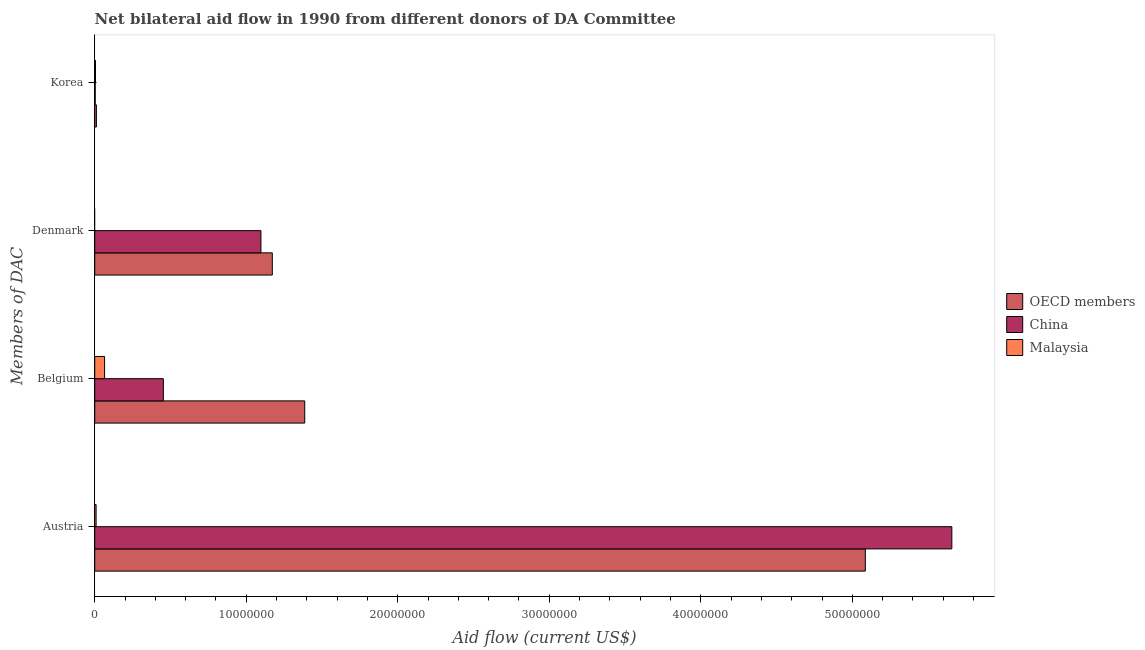How many different coloured bars are there?
Ensure brevity in your answer.  3. How many groups of bars are there?
Your answer should be very brief. 4. Are the number of bars per tick equal to the number of legend labels?
Make the answer very short. No. What is the label of the 1st group of bars from the top?
Ensure brevity in your answer.  Korea. What is the amount of aid given by austria in OECD members?
Provide a succinct answer. 5.09e+07. Across all countries, what is the maximum amount of aid given by korea?
Your response must be concise. 1.10e+05. Across all countries, what is the minimum amount of aid given by denmark?
Your response must be concise. 0. What is the total amount of aid given by denmark in the graph?
Keep it short and to the point. 2.27e+07. What is the difference between the amount of aid given by korea in OECD members and that in Malaysia?
Your answer should be very brief. 6.00e+04. What is the difference between the amount of aid given by denmark in OECD members and the amount of aid given by korea in China?
Offer a very short reply. 1.17e+07. What is the average amount of aid given by belgium per country?
Give a very brief answer. 6.35e+06. What is the difference between the amount of aid given by korea and amount of aid given by denmark in OECD members?
Your answer should be compact. -1.16e+07. In how many countries, is the amount of aid given by korea greater than 4000000 US$?
Your answer should be very brief. 0. What is the ratio of the amount of aid given by belgium in China to that in Malaysia?
Keep it short and to the point. 6.97. Is the difference between the amount of aid given by korea in OECD members and China greater than the difference between the amount of aid given by denmark in OECD members and China?
Offer a very short reply. No. What is the difference between the highest and the second highest amount of aid given by belgium?
Give a very brief answer. 9.33e+06. What is the difference between the highest and the lowest amount of aid given by belgium?
Provide a short and direct response. 1.32e+07. In how many countries, is the amount of aid given by korea greater than the average amount of aid given by korea taken over all countries?
Ensure brevity in your answer.  1. Is the sum of the amount of aid given by korea in China and Malaysia greater than the maximum amount of aid given by belgium across all countries?
Offer a terse response. No. Is it the case that in every country, the sum of the amount of aid given by korea and amount of aid given by denmark is greater than the sum of amount of aid given by austria and amount of aid given by belgium?
Give a very brief answer. No. Are all the bars in the graph horizontal?
Provide a succinct answer. Yes. How many countries are there in the graph?
Your response must be concise. 3. Does the graph contain any zero values?
Provide a succinct answer. Yes. Where does the legend appear in the graph?
Your answer should be compact. Center right. How many legend labels are there?
Give a very brief answer. 3. How are the legend labels stacked?
Provide a succinct answer. Vertical. What is the title of the graph?
Your answer should be compact. Net bilateral aid flow in 1990 from different donors of DA Committee. What is the label or title of the Y-axis?
Keep it short and to the point. Members of DAC. What is the Aid flow (current US$) in OECD members in Austria?
Ensure brevity in your answer.  5.09e+07. What is the Aid flow (current US$) in China in Austria?
Your response must be concise. 5.66e+07. What is the Aid flow (current US$) of Malaysia in Austria?
Keep it short and to the point. 9.00e+04. What is the Aid flow (current US$) of OECD members in Belgium?
Make the answer very short. 1.39e+07. What is the Aid flow (current US$) of China in Belgium?
Your response must be concise. 4.53e+06. What is the Aid flow (current US$) in Malaysia in Belgium?
Offer a very short reply. 6.50e+05. What is the Aid flow (current US$) in OECD members in Denmark?
Make the answer very short. 1.17e+07. What is the Aid flow (current US$) in China in Denmark?
Make the answer very short. 1.10e+07. What is the Aid flow (current US$) of China in Korea?
Provide a succinct answer. 3.00e+04. What is the Aid flow (current US$) in Malaysia in Korea?
Your response must be concise. 5.00e+04. Across all Members of DAC, what is the maximum Aid flow (current US$) in OECD members?
Offer a very short reply. 5.09e+07. Across all Members of DAC, what is the maximum Aid flow (current US$) in China?
Make the answer very short. 5.66e+07. Across all Members of DAC, what is the maximum Aid flow (current US$) in Malaysia?
Keep it short and to the point. 6.50e+05. Across all Members of DAC, what is the minimum Aid flow (current US$) in OECD members?
Provide a succinct answer. 1.10e+05. Across all Members of DAC, what is the minimum Aid flow (current US$) of China?
Your answer should be compact. 3.00e+04. Across all Members of DAC, what is the minimum Aid flow (current US$) in Malaysia?
Your answer should be compact. 0. What is the total Aid flow (current US$) of OECD members in the graph?
Make the answer very short. 7.66e+07. What is the total Aid flow (current US$) in China in the graph?
Provide a short and direct response. 7.21e+07. What is the total Aid flow (current US$) of Malaysia in the graph?
Give a very brief answer. 7.90e+05. What is the difference between the Aid flow (current US$) in OECD members in Austria and that in Belgium?
Make the answer very short. 3.70e+07. What is the difference between the Aid flow (current US$) of China in Austria and that in Belgium?
Offer a very short reply. 5.20e+07. What is the difference between the Aid flow (current US$) in Malaysia in Austria and that in Belgium?
Offer a terse response. -5.60e+05. What is the difference between the Aid flow (current US$) of OECD members in Austria and that in Denmark?
Make the answer very short. 3.91e+07. What is the difference between the Aid flow (current US$) in China in Austria and that in Denmark?
Provide a succinct answer. 4.56e+07. What is the difference between the Aid flow (current US$) in OECD members in Austria and that in Korea?
Your answer should be compact. 5.08e+07. What is the difference between the Aid flow (current US$) in China in Austria and that in Korea?
Offer a terse response. 5.65e+07. What is the difference between the Aid flow (current US$) of Malaysia in Austria and that in Korea?
Your answer should be compact. 4.00e+04. What is the difference between the Aid flow (current US$) of OECD members in Belgium and that in Denmark?
Your response must be concise. 2.14e+06. What is the difference between the Aid flow (current US$) of China in Belgium and that in Denmark?
Ensure brevity in your answer.  -6.44e+06. What is the difference between the Aid flow (current US$) of OECD members in Belgium and that in Korea?
Your answer should be very brief. 1.38e+07. What is the difference between the Aid flow (current US$) in China in Belgium and that in Korea?
Provide a succinct answer. 4.50e+06. What is the difference between the Aid flow (current US$) in OECD members in Denmark and that in Korea?
Provide a succinct answer. 1.16e+07. What is the difference between the Aid flow (current US$) in China in Denmark and that in Korea?
Ensure brevity in your answer.  1.09e+07. What is the difference between the Aid flow (current US$) of OECD members in Austria and the Aid flow (current US$) of China in Belgium?
Provide a short and direct response. 4.63e+07. What is the difference between the Aid flow (current US$) in OECD members in Austria and the Aid flow (current US$) in Malaysia in Belgium?
Offer a very short reply. 5.02e+07. What is the difference between the Aid flow (current US$) in China in Austria and the Aid flow (current US$) in Malaysia in Belgium?
Offer a terse response. 5.59e+07. What is the difference between the Aid flow (current US$) of OECD members in Austria and the Aid flow (current US$) of China in Denmark?
Give a very brief answer. 3.99e+07. What is the difference between the Aid flow (current US$) of OECD members in Austria and the Aid flow (current US$) of China in Korea?
Offer a very short reply. 5.08e+07. What is the difference between the Aid flow (current US$) in OECD members in Austria and the Aid flow (current US$) in Malaysia in Korea?
Make the answer very short. 5.08e+07. What is the difference between the Aid flow (current US$) in China in Austria and the Aid flow (current US$) in Malaysia in Korea?
Provide a short and direct response. 5.65e+07. What is the difference between the Aid flow (current US$) of OECD members in Belgium and the Aid flow (current US$) of China in Denmark?
Offer a very short reply. 2.89e+06. What is the difference between the Aid flow (current US$) of OECD members in Belgium and the Aid flow (current US$) of China in Korea?
Provide a short and direct response. 1.38e+07. What is the difference between the Aid flow (current US$) of OECD members in Belgium and the Aid flow (current US$) of Malaysia in Korea?
Offer a terse response. 1.38e+07. What is the difference between the Aid flow (current US$) of China in Belgium and the Aid flow (current US$) of Malaysia in Korea?
Your answer should be very brief. 4.48e+06. What is the difference between the Aid flow (current US$) of OECD members in Denmark and the Aid flow (current US$) of China in Korea?
Provide a short and direct response. 1.17e+07. What is the difference between the Aid flow (current US$) in OECD members in Denmark and the Aid flow (current US$) in Malaysia in Korea?
Keep it short and to the point. 1.17e+07. What is the difference between the Aid flow (current US$) of China in Denmark and the Aid flow (current US$) of Malaysia in Korea?
Your answer should be compact. 1.09e+07. What is the average Aid flow (current US$) of OECD members per Members of DAC?
Your response must be concise. 1.91e+07. What is the average Aid flow (current US$) in China per Members of DAC?
Ensure brevity in your answer.  1.80e+07. What is the average Aid flow (current US$) of Malaysia per Members of DAC?
Your answer should be compact. 1.98e+05. What is the difference between the Aid flow (current US$) in OECD members and Aid flow (current US$) in China in Austria?
Give a very brief answer. -5.71e+06. What is the difference between the Aid flow (current US$) of OECD members and Aid flow (current US$) of Malaysia in Austria?
Make the answer very short. 5.08e+07. What is the difference between the Aid flow (current US$) of China and Aid flow (current US$) of Malaysia in Austria?
Offer a terse response. 5.65e+07. What is the difference between the Aid flow (current US$) in OECD members and Aid flow (current US$) in China in Belgium?
Your response must be concise. 9.33e+06. What is the difference between the Aid flow (current US$) of OECD members and Aid flow (current US$) of Malaysia in Belgium?
Ensure brevity in your answer.  1.32e+07. What is the difference between the Aid flow (current US$) of China and Aid flow (current US$) of Malaysia in Belgium?
Make the answer very short. 3.88e+06. What is the difference between the Aid flow (current US$) of OECD members and Aid flow (current US$) of China in Denmark?
Provide a short and direct response. 7.50e+05. What is the difference between the Aid flow (current US$) of OECD members and Aid flow (current US$) of Malaysia in Korea?
Your response must be concise. 6.00e+04. What is the ratio of the Aid flow (current US$) in OECD members in Austria to that in Belgium?
Your response must be concise. 3.67. What is the ratio of the Aid flow (current US$) in China in Austria to that in Belgium?
Offer a terse response. 12.49. What is the ratio of the Aid flow (current US$) of Malaysia in Austria to that in Belgium?
Your answer should be very brief. 0.14. What is the ratio of the Aid flow (current US$) of OECD members in Austria to that in Denmark?
Keep it short and to the point. 4.34. What is the ratio of the Aid flow (current US$) of China in Austria to that in Denmark?
Your response must be concise. 5.16. What is the ratio of the Aid flow (current US$) of OECD members in Austria to that in Korea?
Your answer should be very brief. 462.36. What is the ratio of the Aid flow (current US$) of China in Austria to that in Korea?
Offer a very short reply. 1885.67. What is the ratio of the Aid flow (current US$) in OECD members in Belgium to that in Denmark?
Your answer should be very brief. 1.18. What is the ratio of the Aid flow (current US$) of China in Belgium to that in Denmark?
Give a very brief answer. 0.41. What is the ratio of the Aid flow (current US$) of OECD members in Belgium to that in Korea?
Make the answer very short. 126. What is the ratio of the Aid flow (current US$) in China in Belgium to that in Korea?
Give a very brief answer. 151. What is the ratio of the Aid flow (current US$) in Malaysia in Belgium to that in Korea?
Make the answer very short. 13. What is the ratio of the Aid flow (current US$) in OECD members in Denmark to that in Korea?
Offer a very short reply. 106.55. What is the ratio of the Aid flow (current US$) in China in Denmark to that in Korea?
Give a very brief answer. 365.67. What is the difference between the highest and the second highest Aid flow (current US$) in OECD members?
Make the answer very short. 3.70e+07. What is the difference between the highest and the second highest Aid flow (current US$) in China?
Offer a terse response. 4.56e+07. What is the difference between the highest and the second highest Aid flow (current US$) in Malaysia?
Provide a succinct answer. 5.60e+05. What is the difference between the highest and the lowest Aid flow (current US$) in OECD members?
Your response must be concise. 5.08e+07. What is the difference between the highest and the lowest Aid flow (current US$) in China?
Keep it short and to the point. 5.65e+07. What is the difference between the highest and the lowest Aid flow (current US$) of Malaysia?
Offer a very short reply. 6.50e+05. 